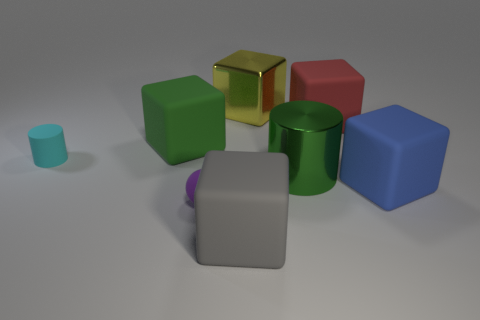Is the number of large green metal objects that are left of the large green rubber block less than the number of tiny red metal blocks?
Make the answer very short. No. What number of shiny objects are small green spheres or large yellow objects?
Provide a succinct answer. 1. Is the sphere the same color as the rubber cylinder?
Your answer should be compact. No. Is there anything else that has the same color as the matte ball?
Keep it short and to the point. No. There is a big matte object on the left side of the gray thing; is its shape the same as the green thing right of the yellow shiny thing?
Keep it short and to the point. No. What number of objects are blue cubes or rubber cubes behind the tiny sphere?
Ensure brevity in your answer.  3. What number of other things are the same size as the red thing?
Offer a very short reply. 5. Does the tiny thing that is in front of the small cyan rubber cylinder have the same material as the small cyan object that is in front of the green matte block?
Your response must be concise. Yes. There is a rubber cylinder; how many large shiny blocks are behind it?
Your answer should be compact. 1. What number of brown objects are big cylinders or matte things?
Give a very brief answer. 0. 